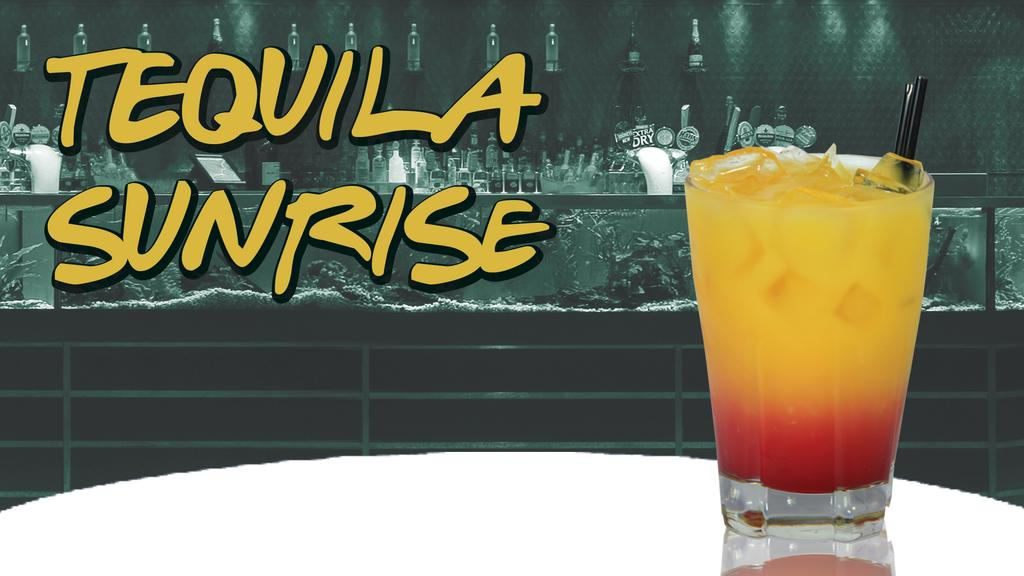What can be observed about the image's appearance? The image is edited. What is contained in the glass in the image? There is a glass with a drink in the image. What is the name of the drink? The name of the drink is visible beside the glass. What can be seen in the background of the image? There are many alcohol bottles in the background of the image. How many family members are present in the image? There is no reference to family members in the image, as it features a glass with a drink and many alcohol bottles in the background. What type of rain is visible in the image? There is no rain present in the image; it is an edited image of a glass with a drink and many alcohol bottles in the background. 